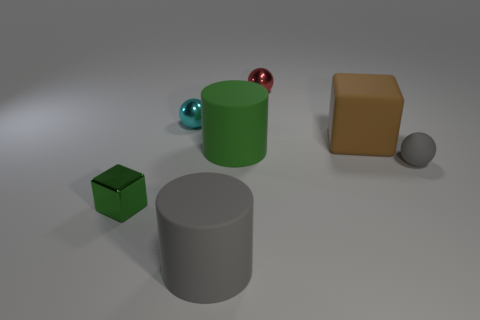Add 3 red metal objects. How many objects exist? 10 Subtract all spheres. How many objects are left? 4 Add 1 small metal things. How many small metal things are left? 4 Add 6 small rubber spheres. How many small rubber spheres exist? 7 Subtract 1 red balls. How many objects are left? 6 Subtract all large blocks. Subtract all blue shiny cubes. How many objects are left? 6 